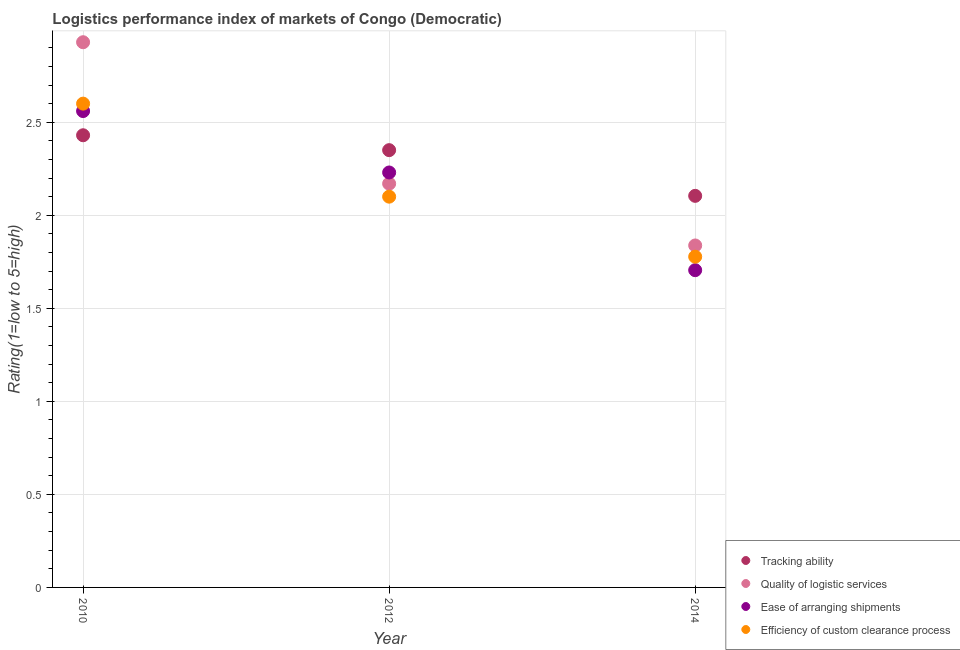What is the lpi rating of ease of arranging shipments in 2012?
Ensure brevity in your answer.  2.23. Across all years, what is the maximum lpi rating of quality of logistic services?
Keep it short and to the point. 2.93. Across all years, what is the minimum lpi rating of ease of arranging shipments?
Keep it short and to the point. 1.7. In which year was the lpi rating of quality of logistic services maximum?
Your answer should be very brief. 2010. In which year was the lpi rating of efficiency of custom clearance process minimum?
Keep it short and to the point. 2014. What is the total lpi rating of tracking ability in the graph?
Keep it short and to the point. 6.88. What is the difference between the lpi rating of quality of logistic services in 2012 and that in 2014?
Your response must be concise. 0.33. What is the difference between the lpi rating of quality of logistic services in 2010 and the lpi rating of efficiency of custom clearance process in 2014?
Offer a terse response. 1.15. What is the average lpi rating of efficiency of custom clearance process per year?
Keep it short and to the point. 2.16. In the year 2010, what is the difference between the lpi rating of efficiency of custom clearance process and lpi rating of tracking ability?
Ensure brevity in your answer.  0.17. In how many years, is the lpi rating of tracking ability greater than 0.1?
Make the answer very short. 3. What is the ratio of the lpi rating of tracking ability in 2010 to that in 2014?
Your answer should be very brief. 1.15. Is the lpi rating of tracking ability in 2012 less than that in 2014?
Offer a very short reply. No. What is the difference between the highest and the lowest lpi rating of ease of arranging shipments?
Offer a terse response. 0.86. Does the lpi rating of ease of arranging shipments monotonically increase over the years?
Your answer should be very brief. No. Is the lpi rating of quality of logistic services strictly greater than the lpi rating of tracking ability over the years?
Ensure brevity in your answer.  No. Is the lpi rating of ease of arranging shipments strictly less than the lpi rating of efficiency of custom clearance process over the years?
Offer a terse response. No. How many dotlines are there?
Your answer should be very brief. 4. What is the difference between two consecutive major ticks on the Y-axis?
Make the answer very short. 0.5. Are the values on the major ticks of Y-axis written in scientific E-notation?
Make the answer very short. No. Where does the legend appear in the graph?
Your answer should be very brief. Bottom right. How many legend labels are there?
Ensure brevity in your answer.  4. How are the legend labels stacked?
Provide a succinct answer. Vertical. What is the title of the graph?
Your response must be concise. Logistics performance index of markets of Congo (Democratic). Does "Burnt food" appear as one of the legend labels in the graph?
Provide a succinct answer. No. What is the label or title of the Y-axis?
Keep it short and to the point. Rating(1=low to 5=high). What is the Rating(1=low to 5=high) in Tracking ability in 2010?
Give a very brief answer. 2.43. What is the Rating(1=low to 5=high) in Quality of logistic services in 2010?
Offer a terse response. 2.93. What is the Rating(1=low to 5=high) in Ease of arranging shipments in 2010?
Offer a very short reply. 2.56. What is the Rating(1=low to 5=high) of Efficiency of custom clearance process in 2010?
Provide a succinct answer. 2.6. What is the Rating(1=low to 5=high) in Tracking ability in 2012?
Give a very brief answer. 2.35. What is the Rating(1=low to 5=high) of Quality of logistic services in 2012?
Your answer should be very brief. 2.17. What is the Rating(1=low to 5=high) in Ease of arranging shipments in 2012?
Give a very brief answer. 2.23. What is the Rating(1=low to 5=high) in Efficiency of custom clearance process in 2012?
Provide a succinct answer. 2.1. What is the Rating(1=low to 5=high) in Tracking ability in 2014?
Make the answer very short. 2.1. What is the Rating(1=low to 5=high) in Quality of logistic services in 2014?
Keep it short and to the point. 1.84. What is the Rating(1=low to 5=high) in Ease of arranging shipments in 2014?
Offer a terse response. 1.7. What is the Rating(1=low to 5=high) in Efficiency of custom clearance process in 2014?
Make the answer very short. 1.78. Across all years, what is the maximum Rating(1=low to 5=high) in Tracking ability?
Offer a terse response. 2.43. Across all years, what is the maximum Rating(1=low to 5=high) of Quality of logistic services?
Offer a terse response. 2.93. Across all years, what is the maximum Rating(1=low to 5=high) in Ease of arranging shipments?
Ensure brevity in your answer.  2.56. Across all years, what is the minimum Rating(1=low to 5=high) in Tracking ability?
Make the answer very short. 2.1. Across all years, what is the minimum Rating(1=low to 5=high) of Quality of logistic services?
Keep it short and to the point. 1.84. Across all years, what is the minimum Rating(1=low to 5=high) of Ease of arranging shipments?
Your response must be concise. 1.7. Across all years, what is the minimum Rating(1=low to 5=high) in Efficiency of custom clearance process?
Keep it short and to the point. 1.78. What is the total Rating(1=low to 5=high) of Tracking ability in the graph?
Give a very brief answer. 6.88. What is the total Rating(1=low to 5=high) of Quality of logistic services in the graph?
Offer a very short reply. 6.94. What is the total Rating(1=low to 5=high) of Ease of arranging shipments in the graph?
Provide a succinct answer. 6.5. What is the total Rating(1=low to 5=high) in Efficiency of custom clearance process in the graph?
Your answer should be very brief. 6.48. What is the difference between the Rating(1=low to 5=high) in Quality of logistic services in 2010 and that in 2012?
Keep it short and to the point. 0.76. What is the difference between the Rating(1=low to 5=high) in Ease of arranging shipments in 2010 and that in 2012?
Give a very brief answer. 0.33. What is the difference between the Rating(1=low to 5=high) in Tracking ability in 2010 and that in 2014?
Provide a short and direct response. 0.33. What is the difference between the Rating(1=low to 5=high) in Quality of logistic services in 2010 and that in 2014?
Keep it short and to the point. 1.09. What is the difference between the Rating(1=low to 5=high) in Ease of arranging shipments in 2010 and that in 2014?
Ensure brevity in your answer.  0.85. What is the difference between the Rating(1=low to 5=high) in Efficiency of custom clearance process in 2010 and that in 2014?
Provide a short and direct response. 0.82. What is the difference between the Rating(1=low to 5=high) in Tracking ability in 2012 and that in 2014?
Provide a short and direct response. 0.25. What is the difference between the Rating(1=low to 5=high) in Quality of logistic services in 2012 and that in 2014?
Ensure brevity in your answer.  0.33. What is the difference between the Rating(1=low to 5=high) in Ease of arranging shipments in 2012 and that in 2014?
Provide a succinct answer. 0.53. What is the difference between the Rating(1=low to 5=high) in Efficiency of custom clearance process in 2012 and that in 2014?
Your answer should be very brief. 0.32. What is the difference between the Rating(1=low to 5=high) in Tracking ability in 2010 and the Rating(1=low to 5=high) in Quality of logistic services in 2012?
Provide a succinct answer. 0.26. What is the difference between the Rating(1=low to 5=high) in Tracking ability in 2010 and the Rating(1=low to 5=high) in Ease of arranging shipments in 2012?
Provide a short and direct response. 0.2. What is the difference between the Rating(1=low to 5=high) in Tracking ability in 2010 and the Rating(1=low to 5=high) in Efficiency of custom clearance process in 2012?
Provide a short and direct response. 0.33. What is the difference between the Rating(1=low to 5=high) in Quality of logistic services in 2010 and the Rating(1=low to 5=high) in Efficiency of custom clearance process in 2012?
Ensure brevity in your answer.  0.83. What is the difference between the Rating(1=low to 5=high) in Ease of arranging shipments in 2010 and the Rating(1=low to 5=high) in Efficiency of custom clearance process in 2012?
Provide a short and direct response. 0.46. What is the difference between the Rating(1=low to 5=high) of Tracking ability in 2010 and the Rating(1=low to 5=high) of Quality of logistic services in 2014?
Offer a very short reply. 0.59. What is the difference between the Rating(1=low to 5=high) in Tracking ability in 2010 and the Rating(1=low to 5=high) in Ease of arranging shipments in 2014?
Keep it short and to the point. 0.72. What is the difference between the Rating(1=low to 5=high) in Tracking ability in 2010 and the Rating(1=low to 5=high) in Efficiency of custom clearance process in 2014?
Provide a succinct answer. 0.65. What is the difference between the Rating(1=low to 5=high) in Quality of logistic services in 2010 and the Rating(1=low to 5=high) in Ease of arranging shipments in 2014?
Provide a short and direct response. 1.23. What is the difference between the Rating(1=low to 5=high) of Quality of logistic services in 2010 and the Rating(1=low to 5=high) of Efficiency of custom clearance process in 2014?
Offer a very short reply. 1.15. What is the difference between the Rating(1=low to 5=high) of Ease of arranging shipments in 2010 and the Rating(1=low to 5=high) of Efficiency of custom clearance process in 2014?
Your answer should be very brief. 0.78. What is the difference between the Rating(1=low to 5=high) in Tracking ability in 2012 and the Rating(1=low to 5=high) in Quality of logistic services in 2014?
Give a very brief answer. 0.51. What is the difference between the Rating(1=low to 5=high) in Tracking ability in 2012 and the Rating(1=low to 5=high) in Ease of arranging shipments in 2014?
Offer a terse response. 0.65. What is the difference between the Rating(1=low to 5=high) of Tracking ability in 2012 and the Rating(1=low to 5=high) of Efficiency of custom clearance process in 2014?
Offer a very short reply. 0.57. What is the difference between the Rating(1=low to 5=high) in Quality of logistic services in 2012 and the Rating(1=low to 5=high) in Ease of arranging shipments in 2014?
Provide a short and direct response. 0.47. What is the difference between the Rating(1=low to 5=high) in Quality of logistic services in 2012 and the Rating(1=low to 5=high) in Efficiency of custom clearance process in 2014?
Give a very brief answer. 0.39. What is the difference between the Rating(1=low to 5=high) in Ease of arranging shipments in 2012 and the Rating(1=low to 5=high) in Efficiency of custom clearance process in 2014?
Your answer should be compact. 0.45. What is the average Rating(1=low to 5=high) of Tracking ability per year?
Your answer should be very brief. 2.29. What is the average Rating(1=low to 5=high) in Quality of logistic services per year?
Your answer should be very brief. 2.31. What is the average Rating(1=low to 5=high) in Ease of arranging shipments per year?
Keep it short and to the point. 2.17. What is the average Rating(1=low to 5=high) of Efficiency of custom clearance process per year?
Your answer should be very brief. 2.16. In the year 2010, what is the difference between the Rating(1=low to 5=high) in Tracking ability and Rating(1=low to 5=high) in Quality of logistic services?
Provide a short and direct response. -0.5. In the year 2010, what is the difference between the Rating(1=low to 5=high) in Tracking ability and Rating(1=low to 5=high) in Ease of arranging shipments?
Your response must be concise. -0.13. In the year 2010, what is the difference between the Rating(1=low to 5=high) in Tracking ability and Rating(1=low to 5=high) in Efficiency of custom clearance process?
Make the answer very short. -0.17. In the year 2010, what is the difference between the Rating(1=low to 5=high) in Quality of logistic services and Rating(1=low to 5=high) in Ease of arranging shipments?
Your answer should be compact. 0.37. In the year 2010, what is the difference between the Rating(1=low to 5=high) in Quality of logistic services and Rating(1=low to 5=high) in Efficiency of custom clearance process?
Your response must be concise. 0.33. In the year 2010, what is the difference between the Rating(1=low to 5=high) in Ease of arranging shipments and Rating(1=low to 5=high) in Efficiency of custom clearance process?
Provide a succinct answer. -0.04. In the year 2012, what is the difference between the Rating(1=low to 5=high) of Tracking ability and Rating(1=low to 5=high) of Quality of logistic services?
Keep it short and to the point. 0.18. In the year 2012, what is the difference between the Rating(1=low to 5=high) of Tracking ability and Rating(1=low to 5=high) of Ease of arranging shipments?
Keep it short and to the point. 0.12. In the year 2012, what is the difference between the Rating(1=low to 5=high) in Tracking ability and Rating(1=low to 5=high) in Efficiency of custom clearance process?
Ensure brevity in your answer.  0.25. In the year 2012, what is the difference between the Rating(1=low to 5=high) of Quality of logistic services and Rating(1=low to 5=high) of Ease of arranging shipments?
Offer a very short reply. -0.06. In the year 2012, what is the difference between the Rating(1=low to 5=high) of Quality of logistic services and Rating(1=low to 5=high) of Efficiency of custom clearance process?
Keep it short and to the point. 0.07. In the year 2012, what is the difference between the Rating(1=low to 5=high) of Ease of arranging shipments and Rating(1=low to 5=high) of Efficiency of custom clearance process?
Your answer should be very brief. 0.13. In the year 2014, what is the difference between the Rating(1=low to 5=high) of Tracking ability and Rating(1=low to 5=high) of Quality of logistic services?
Provide a short and direct response. 0.27. In the year 2014, what is the difference between the Rating(1=low to 5=high) in Tracking ability and Rating(1=low to 5=high) in Ease of arranging shipments?
Offer a very short reply. 0.4. In the year 2014, what is the difference between the Rating(1=low to 5=high) in Tracking ability and Rating(1=low to 5=high) in Efficiency of custom clearance process?
Your answer should be very brief. 0.33. In the year 2014, what is the difference between the Rating(1=low to 5=high) in Quality of logistic services and Rating(1=low to 5=high) in Ease of arranging shipments?
Offer a very short reply. 0.13. In the year 2014, what is the difference between the Rating(1=low to 5=high) in Quality of logistic services and Rating(1=low to 5=high) in Efficiency of custom clearance process?
Your answer should be compact. 0.06. In the year 2014, what is the difference between the Rating(1=low to 5=high) in Ease of arranging shipments and Rating(1=low to 5=high) in Efficiency of custom clearance process?
Provide a short and direct response. -0.07. What is the ratio of the Rating(1=low to 5=high) of Tracking ability in 2010 to that in 2012?
Provide a succinct answer. 1.03. What is the ratio of the Rating(1=low to 5=high) in Quality of logistic services in 2010 to that in 2012?
Your answer should be compact. 1.35. What is the ratio of the Rating(1=low to 5=high) of Ease of arranging shipments in 2010 to that in 2012?
Offer a terse response. 1.15. What is the ratio of the Rating(1=low to 5=high) of Efficiency of custom clearance process in 2010 to that in 2012?
Make the answer very short. 1.24. What is the ratio of the Rating(1=low to 5=high) of Tracking ability in 2010 to that in 2014?
Ensure brevity in your answer.  1.15. What is the ratio of the Rating(1=low to 5=high) in Quality of logistic services in 2010 to that in 2014?
Keep it short and to the point. 1.59. What is the ratio of the Rating(1=low to 5=high) of Ease of arranging shipments in 2010 to that in 2014?
Provide a succinct answer. 1.5. What is the ratio of the Rating(1=low to 5=high) in Efficiency of custom clearance process in 2010 to that in 2014?
Provide a succinct answer. 1.46. What is the ratio of the Rating(1=low to 5=high) of Tracking ability in 2012 to that in 2014?
Give a very brief answer. 1.12. What is the ratio of the Rating(1=low to 5=high) of Quality of logistic services in 2012 to that in 2014?
Provide a short and direct response. 1.18. What is the ratio of the Rating(1=low to 5=high) in Ease of arranging shipments in 2012 to that in 2014?
Offer a very short reply. 1.31. What is the ratio of the Rating(1=low to 5=high) in Efficiency of custom clearance process in 2012 to that in 2014?
Your answer should be compact. 1.18. What is the difference between the highest and the second highest Rating(1=low to 5=high) in Tracking ability?
Offer a very short reply. 0.08. What is the difference between the highest and the second highest Rating(1=low to 5=high) of Quality of logistic services?
Give a very brief answer. 0.76. What is the difference between the highest and the second highest Rating(1=low to 5=high) of Ease of arranging shipments?
Provide a succinct answer. 0.33. What is the difference between the highest and the second highest Rating(1=low to 5=high) of Efficiency of custom clearance process?
Make the answer very short. 0.5. What is the difference between the highest and the lowest Rating(1=low to 5=high) in Tracking ability?
Provide a succinct answer. 0.33. What is the difference between the highest and the lowest Rating(1=low to 5=high) in Quality of logistic services?
Your response must be concise. 1.09. What is the difference between the highest and the lowest Rating(1=low to 5=high) of Ease of arranging shipments?
Give a very brief answer. 0.85. What is the difference between the highest and the lowest Rating(1=low to 5=high) of Efficiency of custom clearance process?
Your answer should be compact. 0.82. 